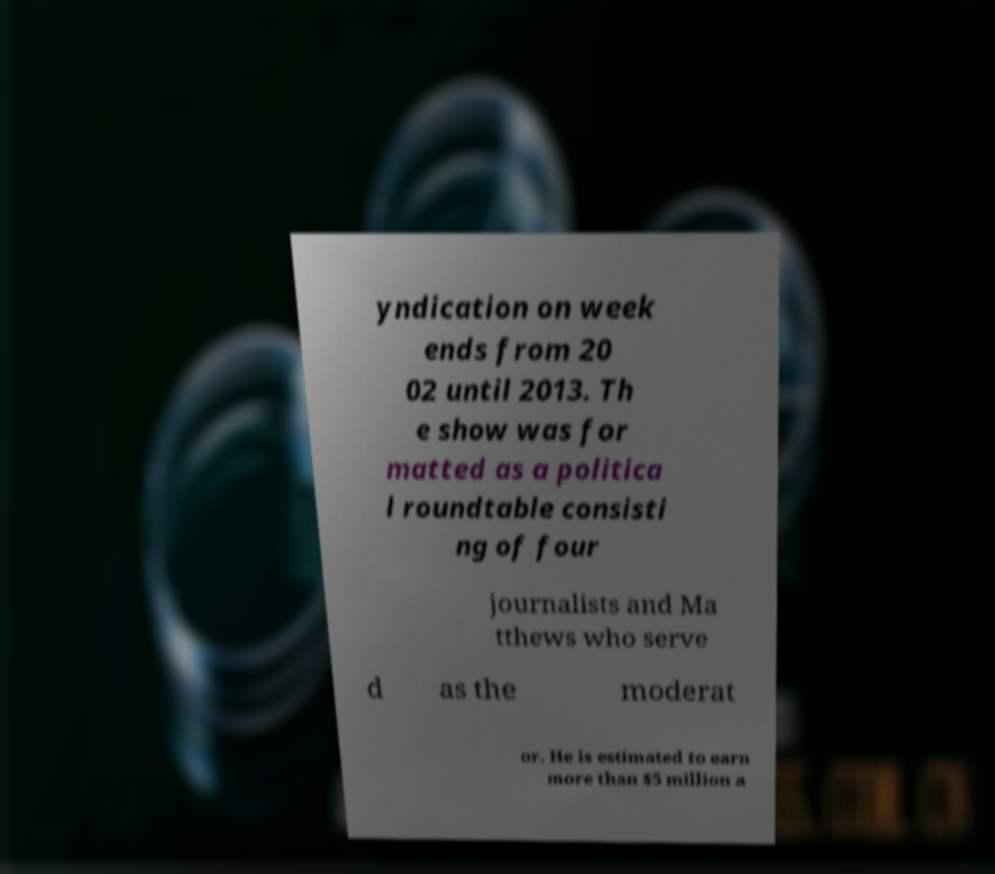For documentation purposes, I need the text within this image transcribed. Could you provide that? yndication on week ends from 20 02 until 2013. Th e show was for matted as a politica l roundtable consisti ng of four journalists and Ma tthews who serve d as the moderat or. He is estimated to earn more than $5 million a 